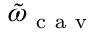<formula> <loc_0><loc_0><loc_500><loc_500>\tilde { \omega } _ { c a v }</formula> 